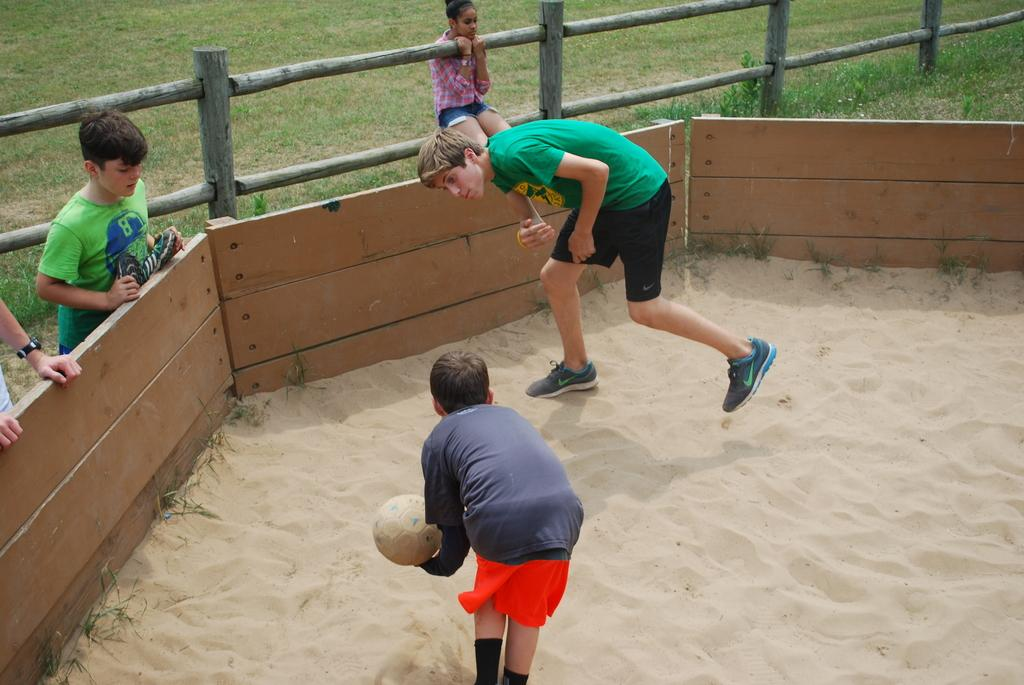What are the two persons in the image doing? The two persons are playing in the image. What object is one of the persons holding? One of the persons is holding a ball. What can be seen in the image that might restrict movement? There are barriers in the image. What type of fence is present in the image? There is a wooden fence in the image. How many persons are in the image in total? There are three persons in the image. What type of ground surface is visible in the image? There is grass in the image. What type of metal object can be seen in the image? There is no metal object present in the image. Can you tell me how many chickens are in the image? There are no chickens present in the image. 